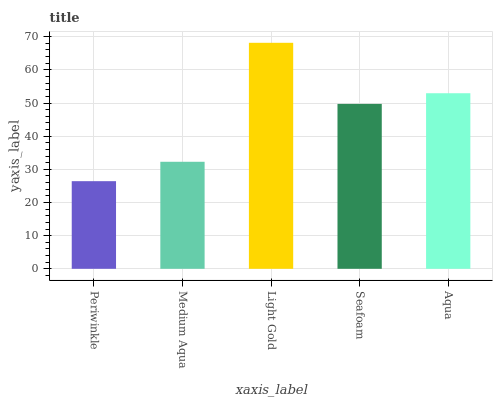Is Medium Aqua the minimum?
Answer yes or no. No. Is Medium Aqua the maximum?
Answer yes or no. No. Is Medium Aqua greater than Periwinkle?
Answer yes or no. Yes. Is Periwinkle less than Medium Aqua?
Answer yes or no. Yes. Is Periwinkle greater than Medium Aqua?
Answer yes or no. No. Is Medium Aqua less than Periwinkle?
Answer yes or no. No. Is Seafoam the high median?
Answer yes or no. Yes. Is Seafoam the low median?
Answer yes or no. Yes. Is Aqua the high median?
Answer yes or no. No. Is Periwinkle the low median?
Answer yes or no. No. 